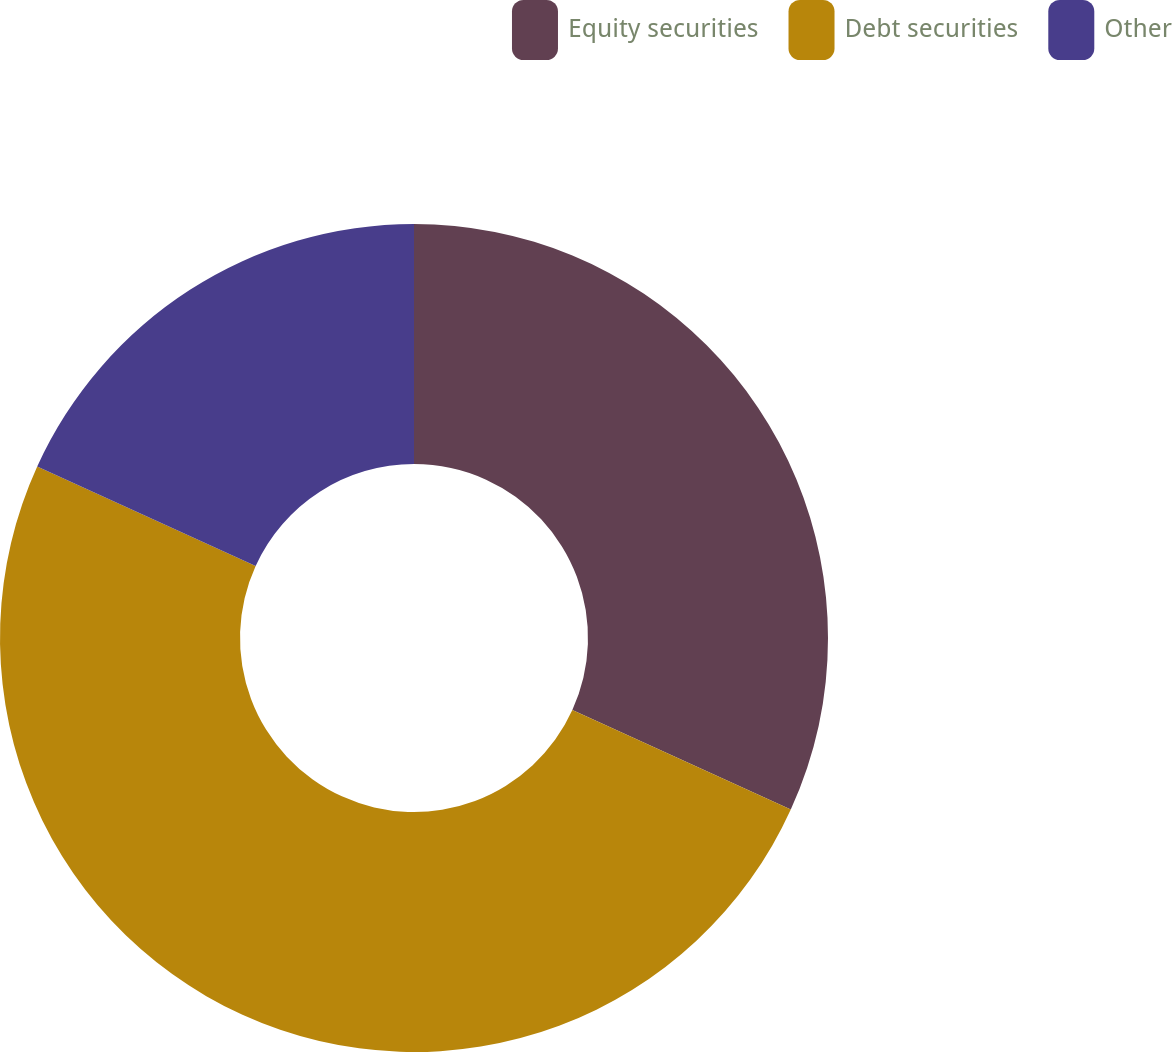Convert chart to OTSL. <chart><loc_0><loc_0><loc_500><loc_500><pie_chart><fcel>Equity securities<fcel>Debt securities<fcel>Other<nl><fcel>31.8%<fcel>50.0%<fcel>18.2%<nl></chart> 